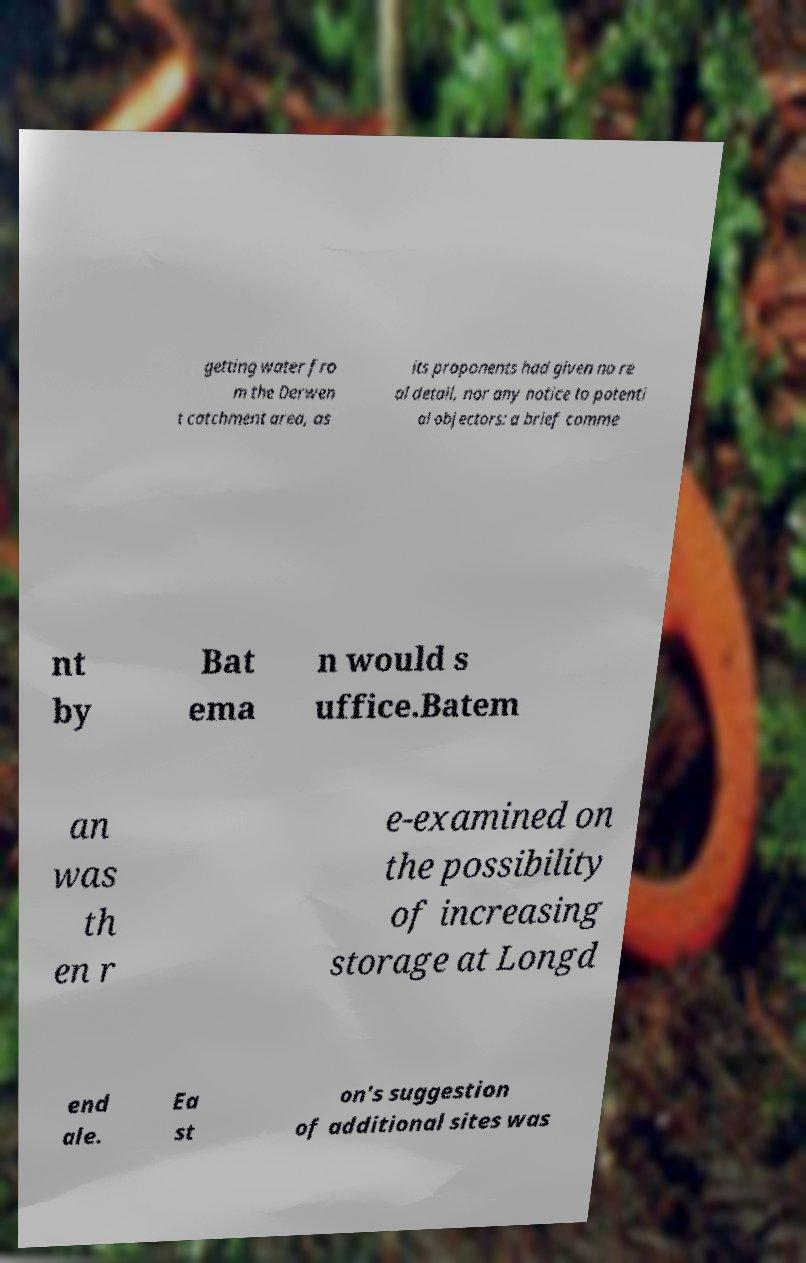There's text embedded in this image that I need extracted. Can you transcribe it verbatim? getting water fro m the Derwen t catchment area, as its proponents had given no re al detail, nor any notice to potenti al objectors: a brief comme nt by Bat ema n would s uffice.Batem an was th en r e-examined on the possibility of increasing storage at Longd end ale. Ea st on's suggestion of additional sites was 